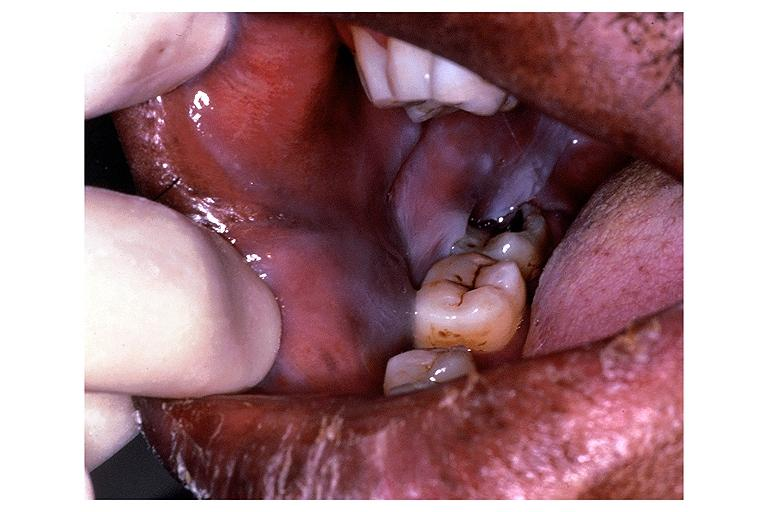what is present?
Answer the question using a single word or phrase. Oral 